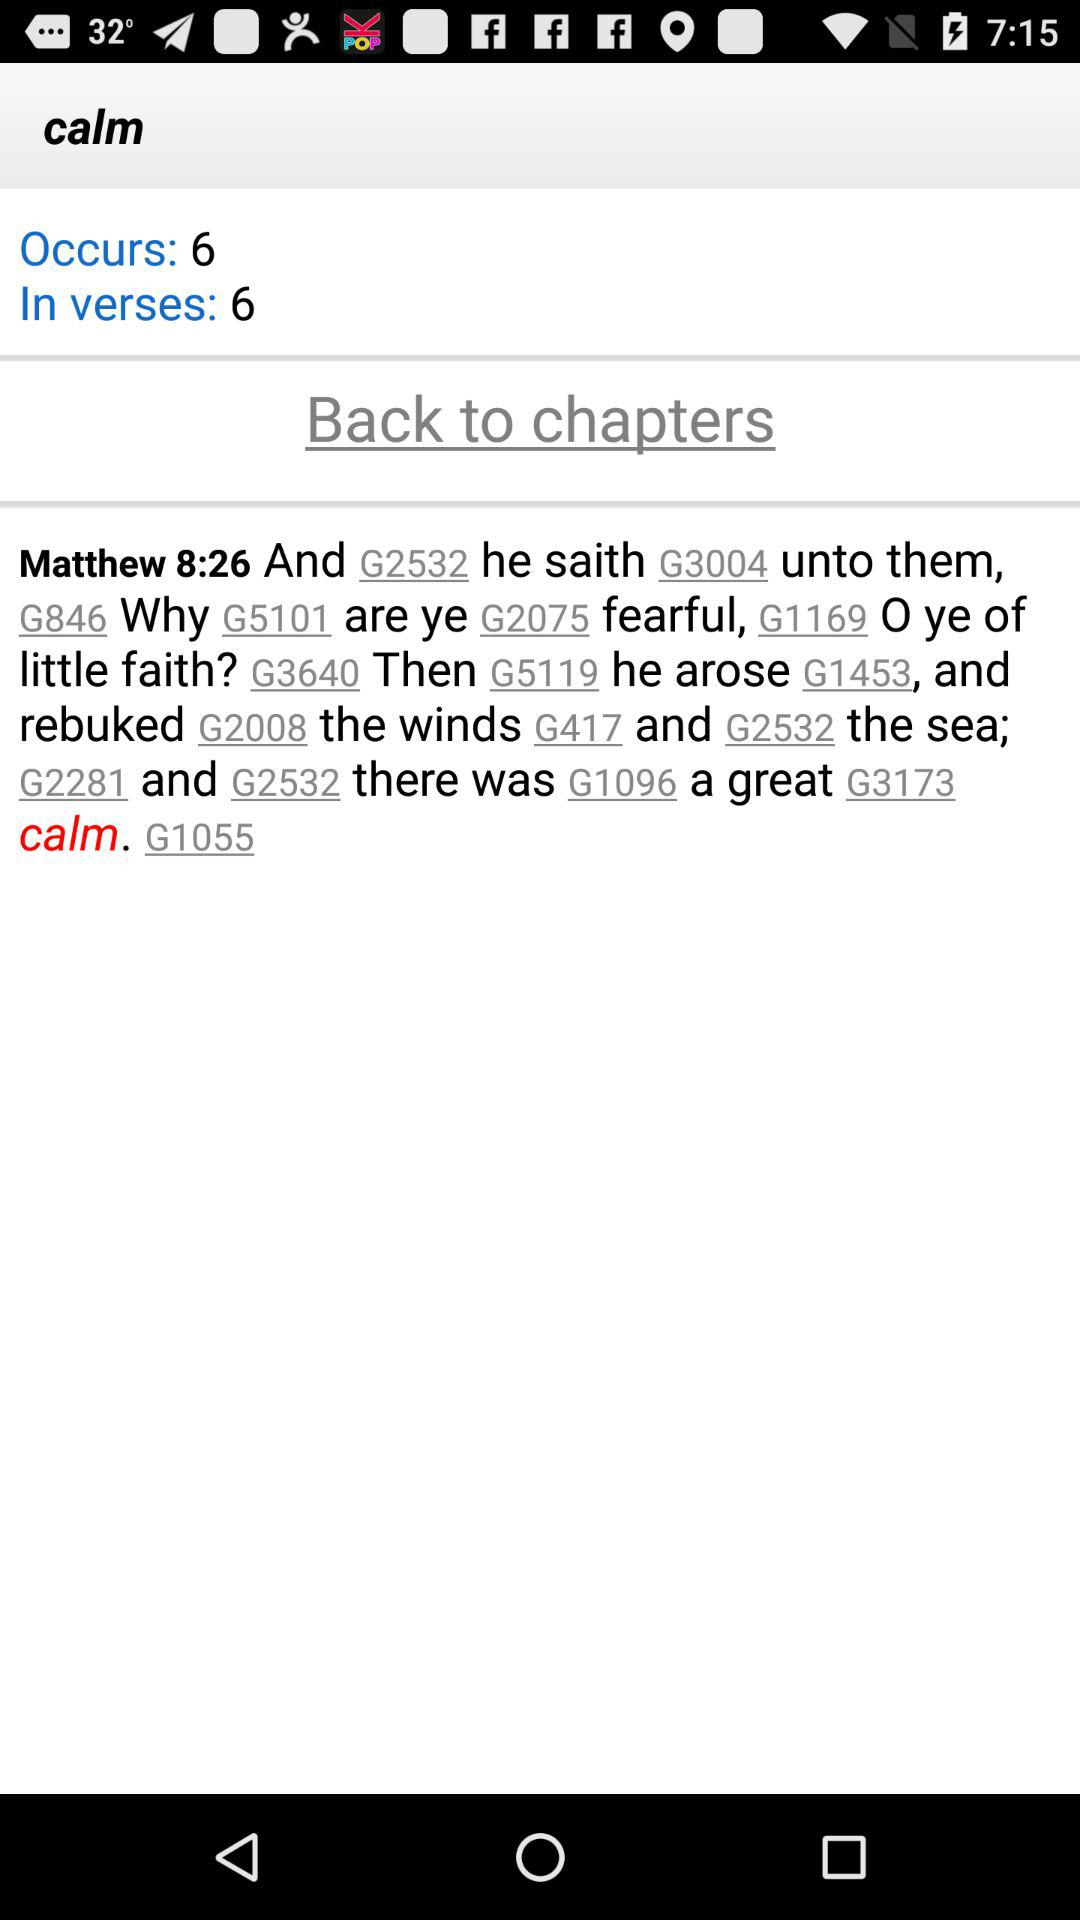What is the count of occurs? The count of occurs is 6. 